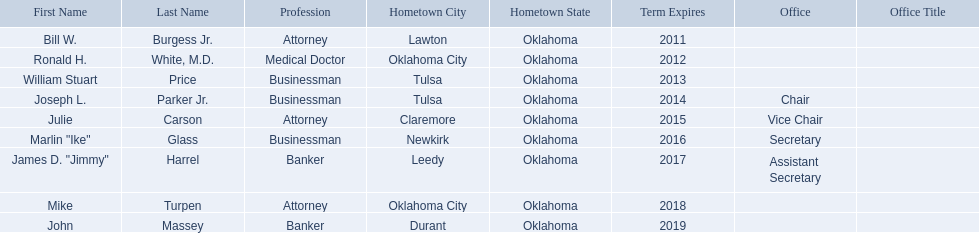What businessmen were born in tulsa? William Stuart Price, Joseph L. Parker Jr. Which man, other than price, was born in tulsa? Joseph L. Parker Jr. 